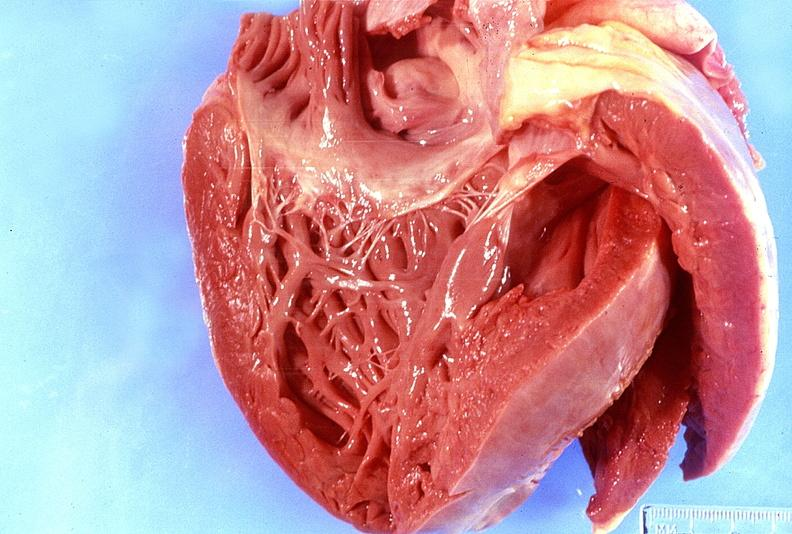what is present?
Answer the question using a single word or phrase. Cardiovascular 